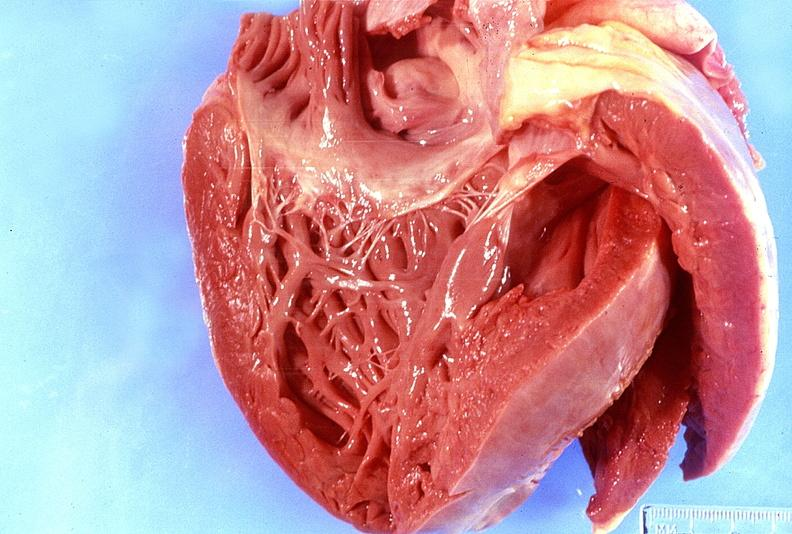what is present?
Answer the question using a single word or phrase. Cardiovascular 